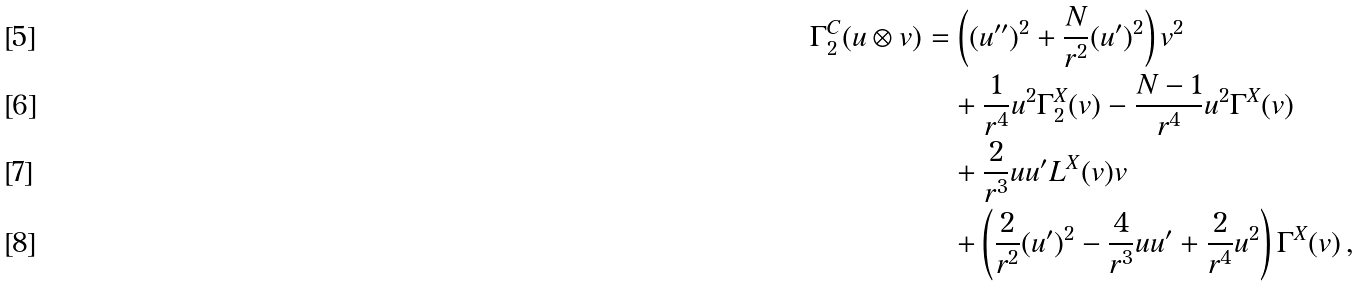Convert formula to latex. <formula><loc_0><loc_0><loc_500><loc_500>\Gamma _ { 2 } ^ { C } ( u \otimes v ) & = \left ( ( u ^ { \prime \prime } ) ^ { 2 } + \frac { N } { r ^ { 2 } } ( u ^ { \prime } ) ^ { 2 } \right ) v ^ { 2 } \\ & \quad + \frac { 1 } { r ^ { 4 } } u ^ { 2 } \Gamma ^ { X } _ { 2 } ( v ) - \frac { N - 1 } { r ^ { 4 } } u ^ { 2 } \Gamma ^ { X } ( v ) \\ & \quad + \frac { 2 } { r ^ { 3 } } u u ^ { \prime } L ^ { X } ( v ) v \\ & \quad + \left ( \frac { 2 } { r ^ { 2 } } ( u ^ { \prime } ) ^ { 2 } - \frac { 4 } { r ^ { 3 } } u u ^ { \prime } + \frac { 2 } { r ^ { 4 } } u ^ { 2 } \right ) \Gamma ^ { X } ( v ) \, ,</formula> 